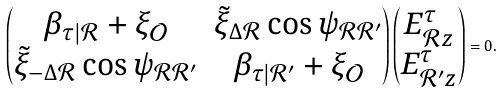Convert formula to latex. <formula><loc_0><loc_0><loc_500><loc_500>\begin{pmatrix} \beta _ { \tau | \mathcal { R } } + \xi _ { \mathcal { O } } & \tilde { \xi } _ { \Delta \mathcal { R } } \cos \psi _ { \mathcal { R } \mathcal { R } ^ { \prime } } \\ \tilde { \xi } _ { - \Delta \mathcal { R } } \cos \psi _ { \mathcal { R } \mathcal { R } ^ { \prime } } & \beta _ { \tau | \mathcal { R } ^ { \prime } } + \xi _ { \mathcal { O } } \end{pmatrix} \begin{pmatrix} E _ { \mathcal { R } z } ^ { \tau } \\ E _ { \mathcal { R } ^ { \prime } z } ^ { \tau } \end{pmatrix} = 0 .</formula> 